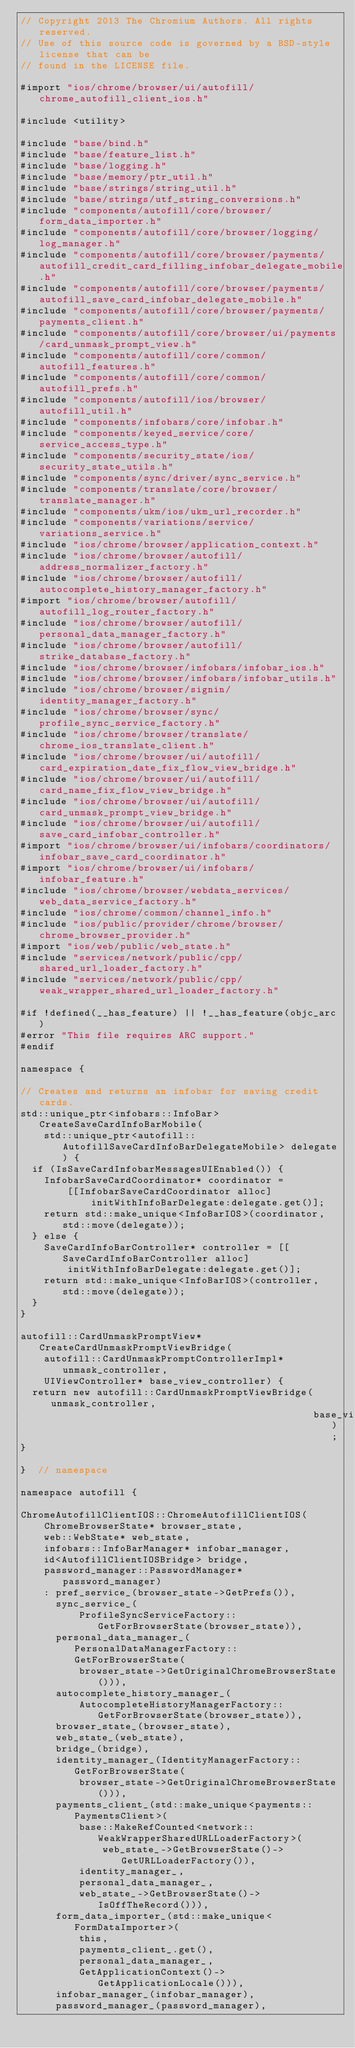Convert code to text. <code><loc_0><loc_0><loc_500><loc_500><_ObjectiveC_>// Copyright 2013 The Chromium Authors. All rights reserved.
// Use of this source code is governed by a BSD-style license that can be
// found in the LICENSE file.

#import "ios/chrome/browser/ui/autofill/chrome_autofill_client_ios.h"

#include <utility>

#include "base/bind.h"
#include "base/feature_list.h"
#include "base/logging.h"
#include "base/memory/ptr_util.h"
#include "base/strings/string_util.h"
#include "base/strings/utf_string_conversions.h"
#include "components/autofill/core/browser/form_data_importer.h"
#include "components/autofill/core/browser/logging/log_manager.h"
#include "components/autofill/core/browser/payments/autofill_credit_card_filling_infobar_delegate_mobile.h"
#include "components/autofill/core/browser/payments/autofill_save_card_infobar_delegate_mobile.h"
#include "components/autofill/core/browser/payments/payments_client.h"
#include "components/autofill/core/browser/ui/payments/card_unmask_prompt_view.h"
#include "components/autofill/core/common/autofill_features.h"
#include "components/autofill/core/common/autofill_prefs.h"
#include "components/autofill/ios/browser/autofill_util.h"
#include "components/infobars/core/infobar.h"
#include "components/keyed_service/core/service_access_type.h"
#include "components/security_state/ios/security_state_utils.h"
#include "components/sync/driver/sync_service.h"
#include "components/translate/core/browser/translate_manager.h"
#include "components/ukm/ios/ukm_url_recorder.h"
#include "components/variations/service/variations_service.h"
#include "ios/chrome/browser/application_context.h"
#include "ios/chrome/browser/autofill/address_normalizer_factory.h"
#include "ios/chrome/browser/autofill/autocomplete_history_manager_factory.h"
#import "ios/chrome/browser/autofill/autofill_log_router_factory.h"
#include "ios/chrome/browser/autofill/personal_data_manager_factory.h"
#include "ios/chrome/browser/autofill/strike_database_factory.h"
#include "ios/chrome/browser/infobars/infobar_ios.h"
#include "ios/chrome/browser/infobars/infobar_utils.h"
#include "ios/chrome/browser/signin/identity_manager_factory.h"
#include "ios/chrome/browser/sync/profile_sync_service_factory.h"
#include "ios/chrome/browser/translate/chrome_ios_translate_client.h"
#include "ios/chrome/browser/ui/autofill/card_expiration_date_fix_flow_view_bridge.h"
#include "ios/chrome/browser/ui/autofill/card_name_fix_flow_view_bridge.h"
#include "ios/chrome/browser/ui/autofill/card_unmask_prompt_view_bridge.h"
#include "ios/chrome/browser/ui/autofill/save_card_infobar_controller.h"
#import "ios/chrome/browser/ui/infobars/coordinators/infobar_save_card_coordinator.h"
#import "ios/chrome/browser/ui/infobars/infobar_feature.h"
#include "ios/chrome/browser/webdata_services/web_data_service_factory.h"
#include "ios/chrome/common/channel_info.h"
#include "ios/public/provider/chrome/browser/chrome_browser_provider.h"
#import "ios/web/public/web_state.h"
#include "services/network/public/cpp/shared_url_loader_factory.h"
#include "services/network/public/cpp/weak_wrapper_shared_url_loader_factory.h"

#if !defined(__has_feature) || !__has_feature(objc_arc)
#error "This file requires ARC support."
#endif

namespace {

// Creates and returns an infobar for saving credit cards.
std::unique_ptr<infobars::InfoBar> CreateSaveCardInfoBarMobile(
    std::unique_ptr<autofill::AutofillSaveCardInfoBarDelegateMobile> delegate) {
  if (IsSaveCardInfobarMessagesUIEnabled()) {
    InfobarSaveCardCoordinator* coordinator =
        [[InfobarSaveCardCoordinator alloc]
            initWithInfoBarDelegate:delegate.get()];
    return std::make_unique<InfoBarIOS>(coordinator, std::move(delegate));
  } else {
    SaveCardInfoBarController* controller = [[SaveCardInfoBarController alloc]
        initWithInfoBarDelegate:delegate.get()];
    return std::make_unique<InfoBarIOS>(controller, std::move(delegate));
  }
}

autofill::CardUnmaskPromptView* CreateCardUnmaskPromptViewBridge(
    autofill::CardUnmaskPromptControllerImpl* unmask_controller,
    UIViewController* base_view_controller) {
  return new autofill::CardUnmaskPromptViewBridge(unmask_controller,
                                                  base_view_controller);
}

}  // namespace

namespace autofill {

ChromeAutofillClientIOS::ChromeAutofillClientIOS(
    ChromeBrowserState* browser_state,
    web::WebState* web_state,
    infobars::InfoBarManager* infobar_manager,
    id<AutofillClientIOSBridge> bridge,
    password_manager::PasswordManager* password_manager)
    : pref_service_(browser_state->GetPrefs()),
      sync_service_(
          ProfileSyncServiceFactory::GetForBrowserState(browser_state)),
      personal_data_manager_(PersonalDataManagerFactory::GetForBrowserState(
          browser_state->GetOriginalChromeBrowserState())),
      autocomplete_history_manager_(
          AutocompleteHistoryManagerFactory::GetForBrowserState(browser_state)),
      browser_state_(browser_state),
      web_state_(web_state),
      bridge_(bridge),
      identity_manager_(IdentityManagerFactory::GetForBrowserState(
          browser_state->GetOriginalChromeBrowserState())),
      payments_client_(std::make_unique<payments::PaymentsClient>(
          base::MakeRefCounted<network::WeakWrapperSharedURLLoaderFactory>(
              web_state_->GetBrowserState()->GetURLLoaderFactory()),
          identity_manager_,
          personal_data_manager_,
          web_state_->GetBrowserState()->IsOffTheRecord())),
      form_data_importer_(std::make_unique<FormDataImporter>(
          this,
          payments_client_.get(),
          personal_data_manager_,
          GetApplicationContext()->GetApplicationLocale())),
      infobar_manager_(infobar_manager),
      password_manager_(password_manager),</code> 